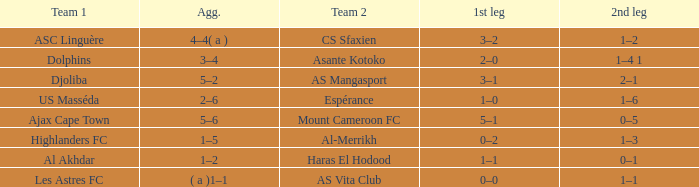What is the 2nd leg of team 1 Dolphins? 1–4 1. 